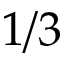<formula> <loc_0><loc_0><loc_500><loc_500>1 / 3</formula> 